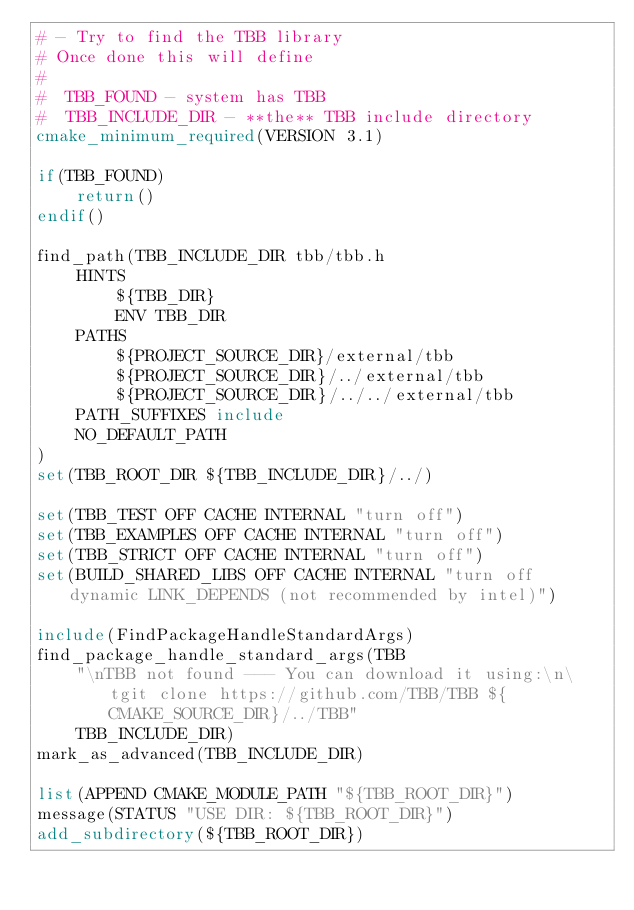<code> <loc_0><loc_0><loc_500><loc_500><_CMake_># - Try to find the TBB library
# Once done this will define
#
#  TBB_FOUND - system has TBB
#  TBB_INCLUDE_DIR - **the** TBB include directory
cmake_minimum_required(VERSION 3.1)

if(TBB_FOUND)
    return()
endif()

find_path(TBB_INCLUDE_DIR tbb/tbb.h
    HINTS
        ${TBB_DIR}
        ENV TBB_DIR
    PATHS
        ${PROJECT_SOURCE_DIR}/external/tbb
        ${PROJECT_SOURCE_DIR}/../external/tbb
        ${PROJECT_SOURCE_DIR}/../../external/tbb
    PATH_SUFFIXES include
    NO_DEFAULT_PATH
)
set(TBB_ROOT_DIR ${TBB_INCLUDE_DIR}/../)

set(TBB_TEST OFF CACHE INTERNAL "turn off")
set(TBB_EXAMPLES OFF CACHE INTERNAL "turn off")
set(TBB_STRICT OFF CACHE INTERNAL "turn off")
set(BUILD_SHARED_LIBS OFF CACHE INTERNAL "turn off dynamic LINK_DEPENDS (not recommended by intel)")

include(FindPackageHandleStandardArgs)
find_package_handle_standard_args(TBB
    "\nTBB not found --- You can download it using:\n\tgit clone https://github.com/TBB/TBB ${CMAKE_SOURCE_DIR}/../TBB"
    TBB_INCLUDE_DIR)
mark_as_advanced(TBB_INCLUDE_DIR)

list(APPEND CMAKE_MODULE_PATH "${TBB_ROOT_DIR}")
message(STATUS "USE DIR: ${TBB_ROOT_DIR}")
add_subdirectory(${TBB_ROOT_DIR})</code> 